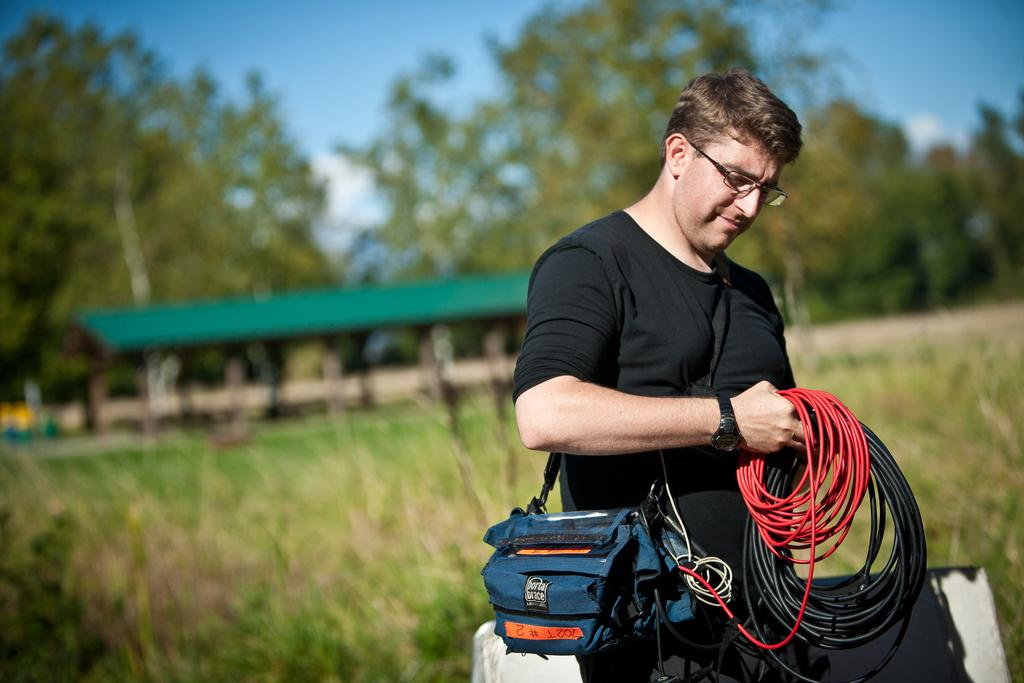What is the person in the image holding? The person in the image is holding wires. What can be seen in the background of the image? There are trees in the background of the image. What type of vegetation is on the ground in the image? There is grass on the ground in the image. What type of veil is draped over the person's toes in the image? There is no veil or reference to toes in the image; the person is holding wires, and the background features trees. 